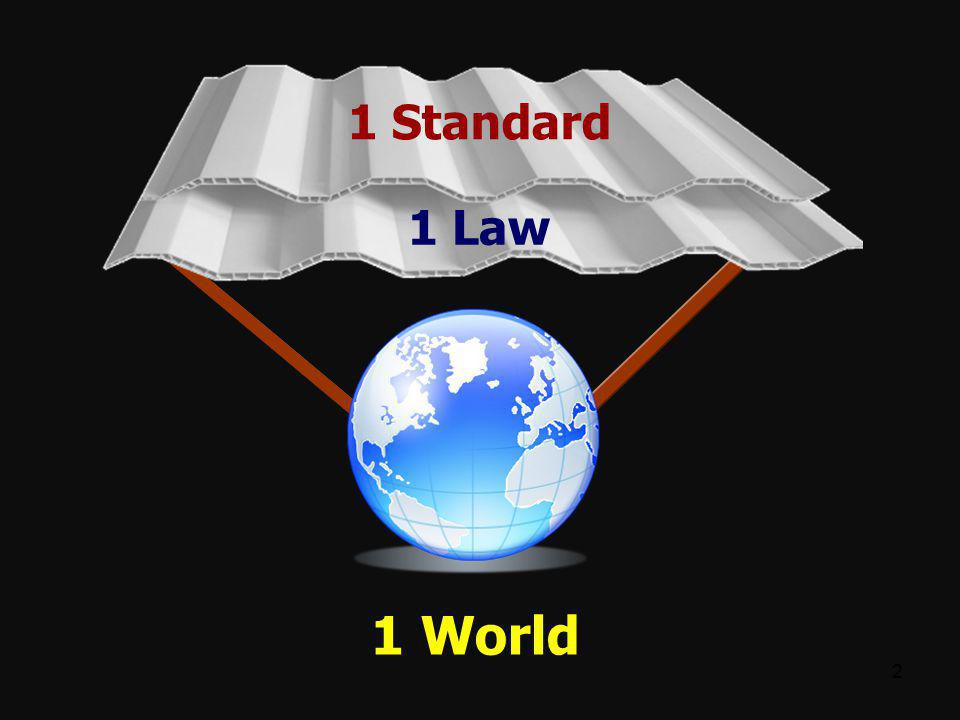What real-world scenario could exemplify the idea of '1 Standard', '1 Law', and '1 World'? A real-world scenario that exemplifies this idea could be the creation of an International Environmental Protection Law adopted by all nations. This single law would set a universal standard for protecting the environment, addressing issues such as pollution, conservation, and climate change. By unifying environmental efforts globally, the world community could more effectively tackle ecological issues, ensuring a balanced and sustainable future for our planet. 